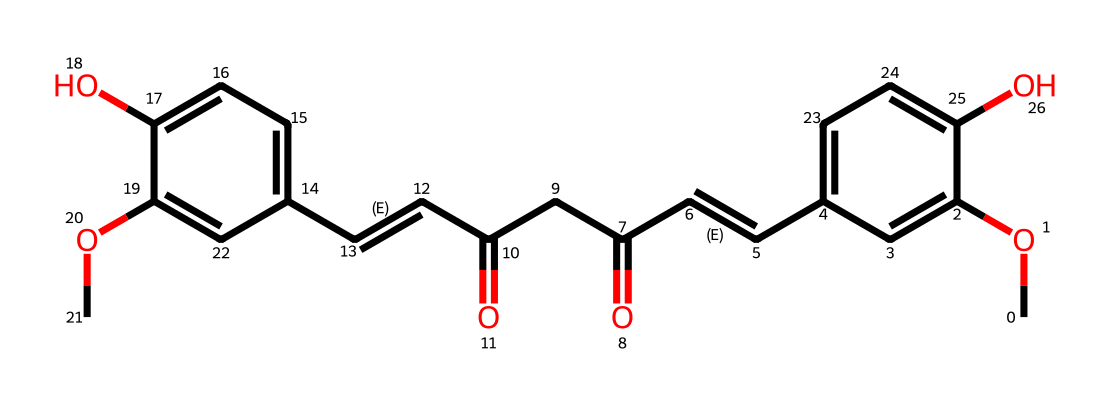What is the molecular formula for curcumin based on the SMILES representation? To determine the molecular formula, we can analyze the SMILES structure for the number of each type of atom present. In this structure, we count a total of 21 carbons (C), 20 hydrogens (H), and 6 oxygens (O). Therefore, the molecular formula based on this count is C21H20O6.
Answer: C21H20O6 How many double bonds are present in curcumin? By examining the SMILES representation, we identify the double bonds indicated by "/C=C/". There are two instances of "C=C" in the structure, confirming that there are two double bonds in curcumin.
Answer: 2 What functional groups are present in curcumin? The SMILES representation indicates the presence of hydroxyl groups (–OH) and carbonyl groups (C=O). The two "O" atoms connected to "c" indicate hydroxyls, and the "C(=O)" units denote carbonyls. This confirms that curcumin possesses both hydroxyl and carbonyl functional groups.
Answer: hydroxyl and carbonyl Does curcumin exhibit antioxidant properties? Curcumin is known for its antioxidant properties due to its ability to donate electrons, which is often associated with the presence of conjugated systems and functional groups such as hydroxyls. This structure supports the claim that curcumin functions effectively as an antioxidant.
Answer: yes How many aromatic rings can be identified in curcumin's structure? By analyzing the structure, we find that curcumin contains two distinct aromatic rings based on the "c" notation in the SMILES representation, suggesting the presence of two aromatic systems within the molecule.
Answer: 2 